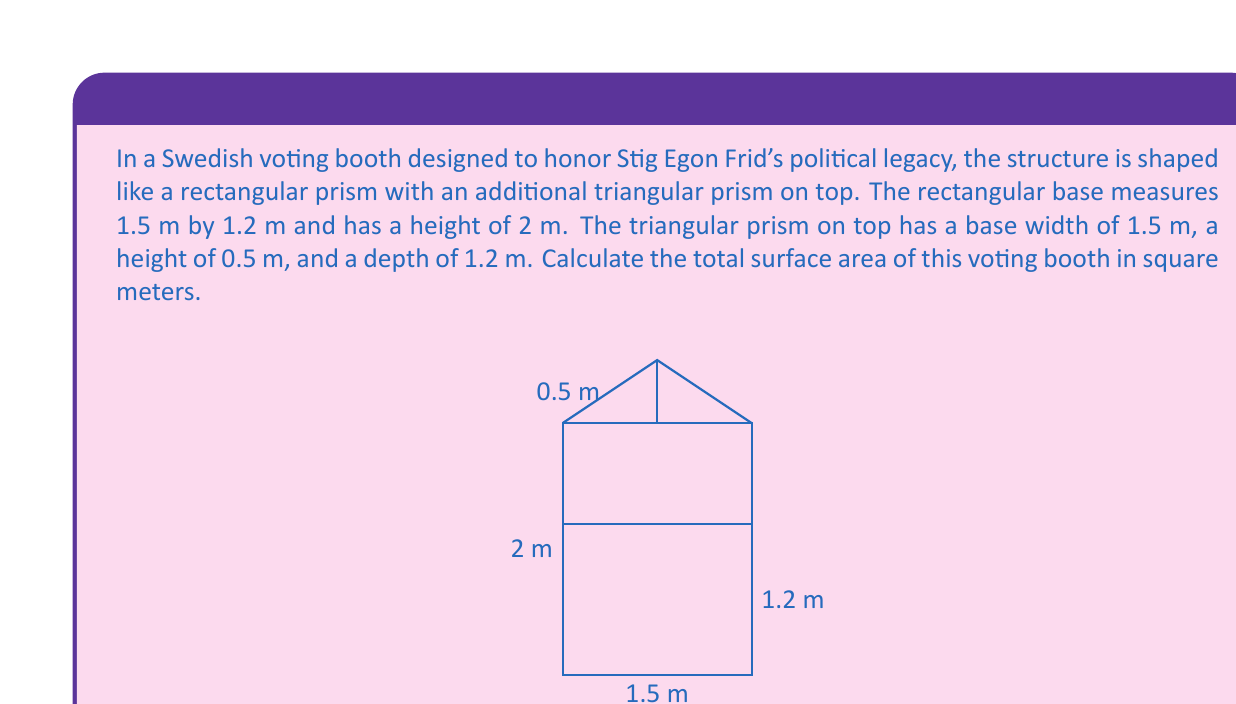Can you solve this math problem? To calculate the total surface area, we need to find the areas of all faces of both the rectangular prism and the triangular prism, then sum them up.

1. Rectangular Prism:
   - Front and back: $2 \times (1.5 \text{ m} \times 2 \text{ m}) = 6 \text{ m}^2$
   - Left and right: $2 \times (1.2 \text{ m} \times 2 \text{ m}) = 4.8 \text{ m}^2$
   - Bottom: $1.5 \text{ m} \times 1.2 \text{ m} = 1.8 \text{ m}^2$

2. Triangular Prism:
   - Front and back triangles: $2 \times (\frac{1}{2} \times 1.5 \text{ m} \times 0.5 \text{ m}) = 0.75 \text{ m}^2$
   - Rectangular sides: $2 \times (1.2 \text{ m} \times 0.5 \text{ m}) = 1.2 \text{ m}^2$
   - Slant surface: $1.5 \text{ m} \times 1.2 \text{ m} = 1.8 \text{ m}^2$

Total surface area:
$$\begin{align*}
A_{total} &= (6 + 4.8 + 1.8 + 0.75 + 1.2 + 1.8) \text{ m}^2 \\
&= 16.35 \text{ m}^2
\end{align*}$$
Answer: The total surface area of the voting booth is $16.35 \text{ m}^2$. 